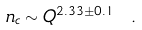Convert formula to latex. <formula><loc_0><loc_0><loc_500><loc_500>n _ { c } \sim Q ^ { 2 . 3 3 \pm 0 . 1 } \ .</formula> 